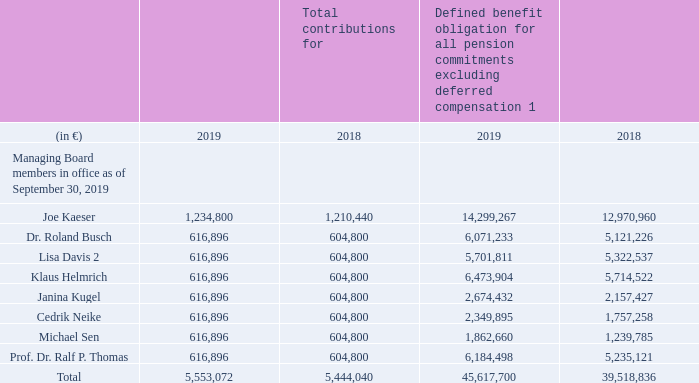Pension benefit commitments
For fiscal 2019, Managing Board members were granted contributions under the BSAV totaling € 5.6 million (2018: € 5.4 million), based on a Supervisory Board decision from November 7, 2019. Of this amount, € 0.02 million (2018: € 0.03 million) relates to the funding of pension commitments earned prior to the transfer to the BSAV.
The expense recognized in fiscal 2019 as a service cost under IFRS for Managing Board members’ entitlements under the BSAV in fiscal 2019 totaled € 5.4 million (2018: € 5.3 million).
Contributions under the BSAV are added to the individual pension accounts in the January following each fiscal year. Until pension payments begin, members’ pension accounts are credited with an annual interest payment (guaranteed interest) on January 1 of each year. The interest rate is currently 0.90%.
The following table shows the individualized contributions (allocations) under the BSAV for fiscal 2019 as well as the defined benefit obligations for pension commitments:
In fiscal 2019, former members of the Managing Board and their surviving dependents received emoluments within the meaning of Section 314 para. 1 No. 6 b of the German Commercial Code totaling € 21.09 million (2018: € 39.9 million).
The defined benefit obligation (DBO) of all pension commitments to former members of the Managing Board and their surviving dependents as of September 30, 2019, amounted to €175.7 million (2018: €168.2 million). This figure is included in NOTE 17 in B.6 NOTES TO CONSOLIDATED FINANCIAL STATEMENTS.
1 Deferred compensation totals € 4,125,612 (2018: € 4,115,237), including € 3,703,123 for Joe Kaeser (2018: € 3,694,439), € 361,494 for Klaus Helmrich (2018: € 362,606) and € 60,995 for Prof. Dr. Ralf P. Thomas (2018: € 58,192).
2 In accordance with the provisions of the BSAV, benefits to be paid to Lisa Davis are not in any way secured or funded through the trust associated with the Company’s BSAV plan or with any other trust. They represent only an unsecured, unfunded legal obligation on the part of the Company to pay such benefits in the future under certain conditions, and the payout will only be made from the Company’s general assets.
What was the expense recognized in fiscal 2019 as a service cost under IFRS for Managing Board members’ entitlements amount to? € 5.6 million. What is the current interest rate? 0.90%. What was The defined benefit obligation (DBO) of all pension commitments to former members of the Managing Board and their surviving dependents as of September 30, 2019 amount to? €175.7 million. What was the increase in Joe Kaeser salary from 2018 to 2019?
Answer scale should be: million. 1,234,800 - 1,210,440
Answer: 24360. What is the percentage increase / (decrease) of Cedrik Neike's salary from 2018 to 2019?
Answer scale should be: percent. 616,896 / 604,800 - 1
Answer: 2. What percentage of total compensation was Michael Sen's salary?
Answer scale should be: percent. 616,896 / 5,553,072
Answer: 11.11. 